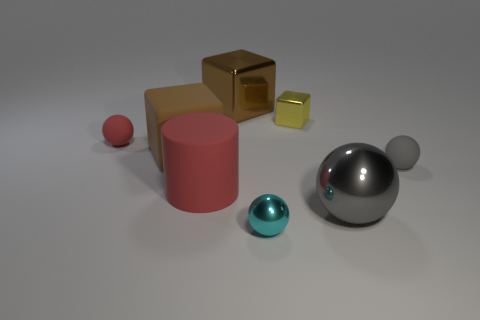Is there any indication of the size or scale of these objects? Without a reference object for scale, it's difficult to determine their exact size. However, the objects are depicted with shadows and proportions that can suggest they are small enough to be held in hand, like desk ornaments or geometric models. 